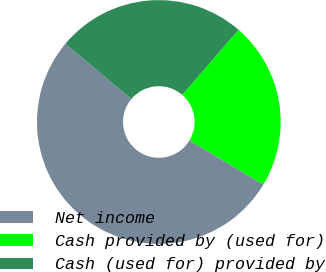Convert chart. <chart><loc_0><loc_0><loc_500><loc_500><pie_chart><fcel>Net income<fcel>Cash provided by (used for)<fcel>Cash (used for) provided by<nl><fcel>52.5%<fcel>22.24%<fcel>25.26%<nl></chart> 